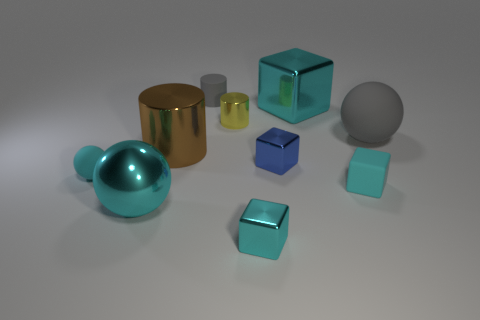Subtract all red spheres. How many cyan cubes are left? 3 Subtract all blocks. How many objects are left? 6 Add 5 big metal things. How many big metal things are left? 8 Add 5 gray rubber things. How many gray rubber things exist? 7 Subtract 3 cyan blocks. How many objects are left? 7 Subtract all big gray matte cylinders. Subtract all small matte things. How many objects are left? 7 